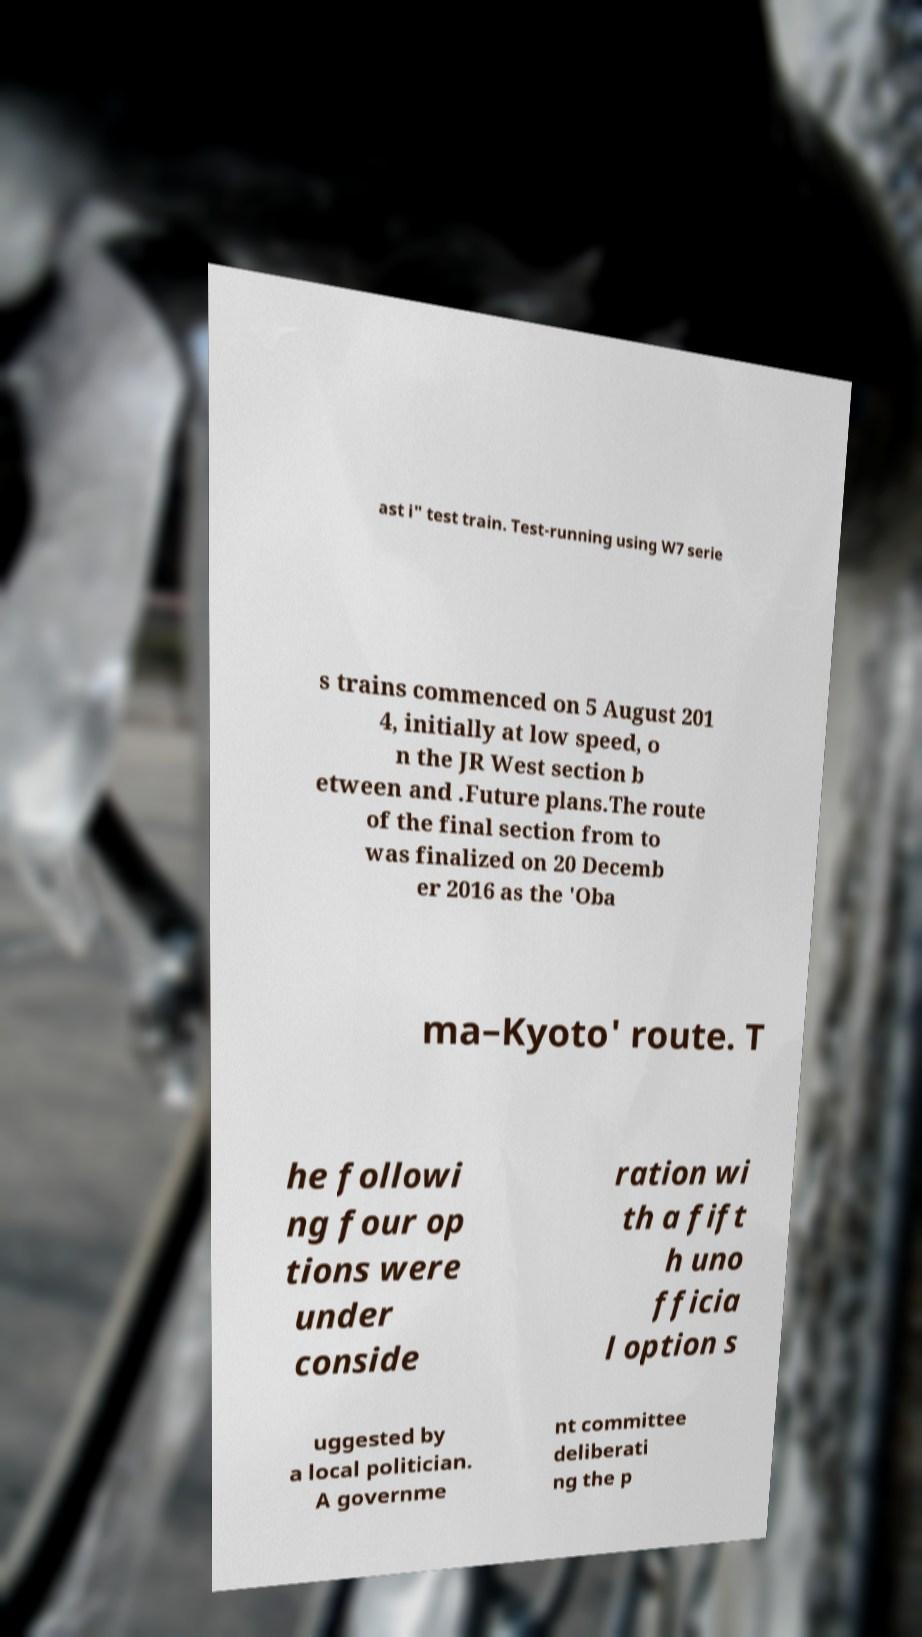For documentation purposes, I need the text within this image transcribed. Could you provide that? ast i" test train. Test-running using W7 serie s trains commenced on 5 August 201 4, initially at low speed, o n the JR West section b etween and .Future plans.The route of the final section from to was finalized on 20 Decemb er 2016 as the 'Oba ma–Kyoto' route. T he followi ng four op tions were under conside ration wi th a fift h uno fficia l option s uggested by a local politician. A governme nt committee deliberati ng the p 